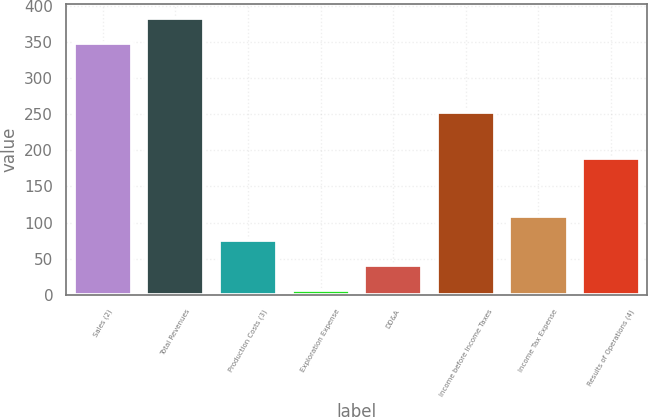Convert chart. <chart><loc_0><loc_0><loc_500><loc_500><bar_chart><fcel>Sales (2)<fcel>Total Revenues<fcel>Production Costs (3)<fcel>Exploration Expense<fcel>DD&A<fcel>Income before Income Taxes<fcel>Income Tax Expense<fcel>Results of Operations (4)<nl><fcel>349<fcel>383.2<fcel>75.4<fcel>7<fcel>41.2<fcel>253<fcel>109.6<fcel>190<nl></chart> 